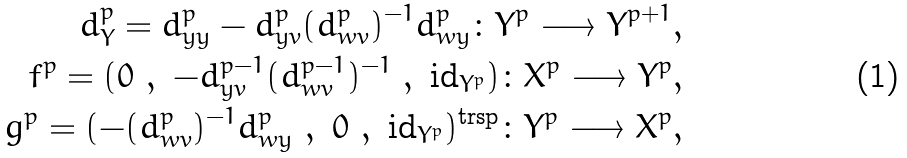<formula> <loc_0><loc_0><loc_500><loc_500>d ^ { p } _ { Y } = d ^ { p } _ { y y } - d ^ { p } _ { y v } ( d ^ { p } _ { w v } ) ^ { - 1 } d ^ { p } _ { w y } \colon Y ^ { p } \longrightarrow Y ^ { p + 1 } , \\ f ^ { p } = ( 0 \ , \ - d ^ { p - 1 } _ { y v } ( d ^ { p - 1 } _ { w v } ) ^ { - 1 } \ , \ { \text {id} } _ { Y ^ { p } } ) \colon X ^ { p } \longrightarrow Y ^ { p } , \\ g ^ { p } = ( - ( d ^ { p } _ { w v } ) ^ { - 1 } d ^ { p } _ { w y } \ , \ 0 \ , \ { \text {id} } _ { Y ^ { p } } ) ^ { \text {trsp} } \colon Y ^ { p } \longrightarrow X ^ { p } ,</formula> 